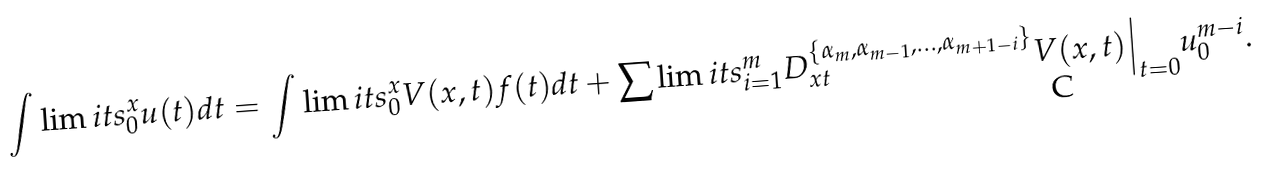Convert formula to latex. <formula><loc_0><loc_0><loc_500><loc_500>\int \lim i t s _ { 0 } ^ { x } u ( t ) d t = \int \lim i t s _ { 0 } ^ { x } V ( x , t ) f ( t ) d t + \sum \lim i t s _ { i = 1 } ^ { m } D _ { x t } ^ { \{ \alpha _ { m } , \alpha _ { m - 1 } , \dots , \alpha _ { m + 1 - i } \} } V ( x , t ) \Big | _ { t = 0 } u _ { 0 } ^ { m - i } .</formula> 